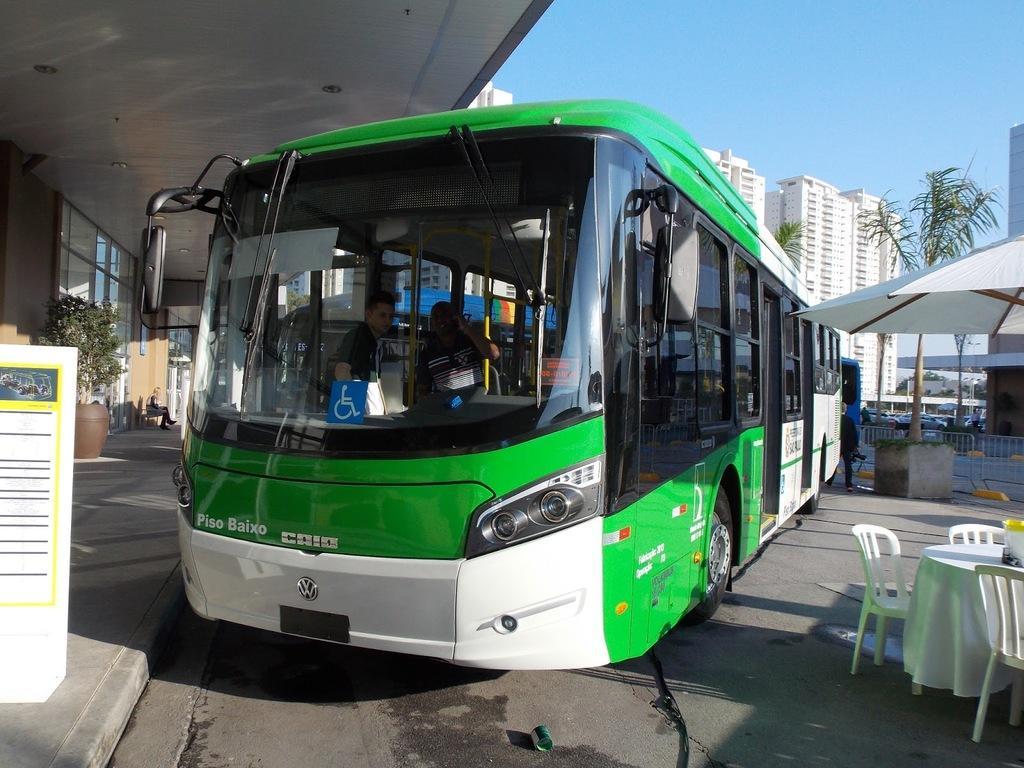Could you give a brief overview of what you see in this image? In this image we can see a bus,table,chair. At the back side we can see a building. 